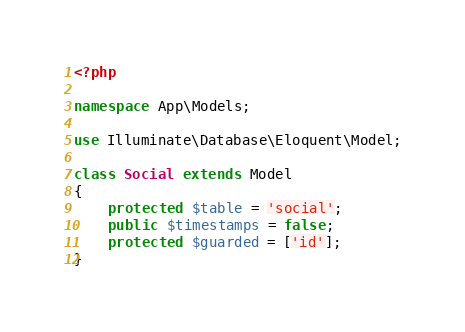Convert code to text. <code><loc_0><loc_0><loc_500><loc_500><_PHP_><?php

namespace App\Models;

use Illuminate\Database\Eloquent\Model;

class Social extends Model
{
    protected $table = 'social';
    public $timestamps = false;
    protected $guarded = ['id'];
}
</code> 